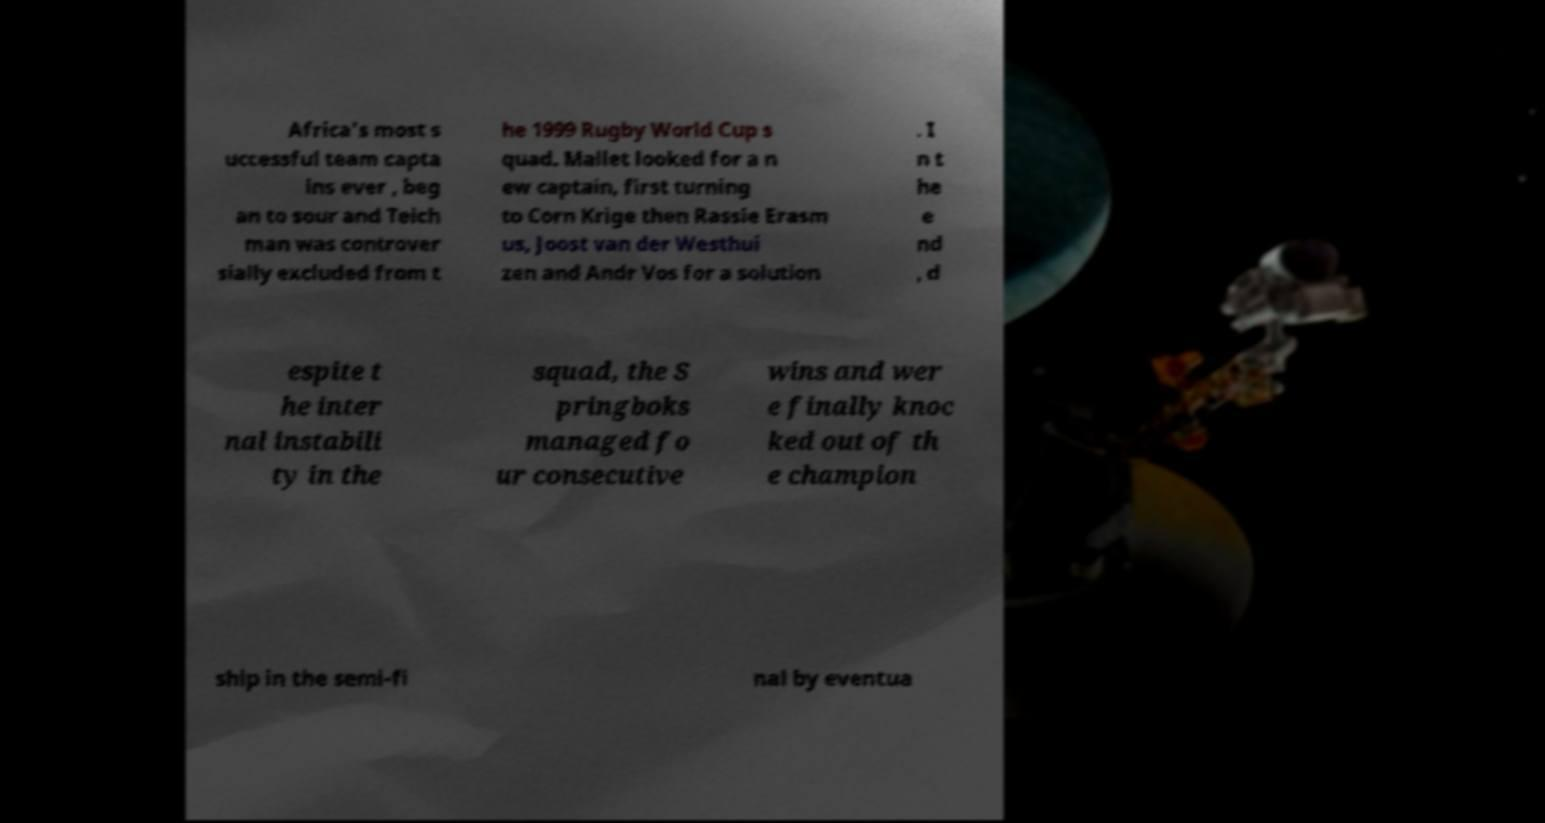Please read and relay the text visible in this image. What does it say? Africa's most s uccessful team capta ins ever , beg an to sour and Teich man was controver sially excluded from t he 1999 Rugby World Cup s quad. Mallet looked for a n ew captain, first turning to Corn Krige then Rassie Erasm us, Joost van der Westhui zen and Andr Vos for a solution . I n t he e nd , d espite t he inter nal instabili ty in the squad, the S pringboks managed fo ur consecutive wins and wer e finally knoc ked out of th e champion ship in the semi-fi nal by eventua 